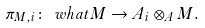Convert formula to latex. <formula><loc_0><loc_0><loc_500><loc_500>\pi _ { M , i } \colon \ w h a t { M } \to A _ { i } \otimes _ { A } M .</formula> 